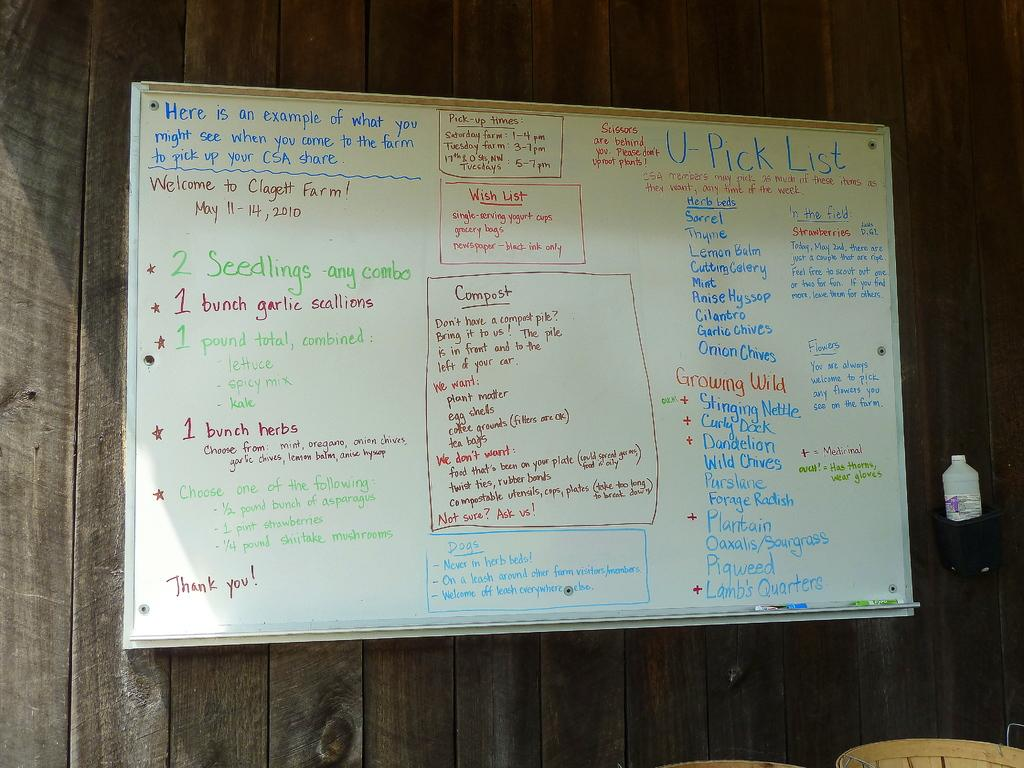Provide a one-sentence caption for the provided image. A large, dry erase white board has several item listed that are included in one of their packages at Clagett Farm. 